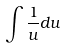Convert formula to latex. <formula><loc_0><loc_0><loc_500><loc_500>\int \frac { 1 } { u } d u</formula> 